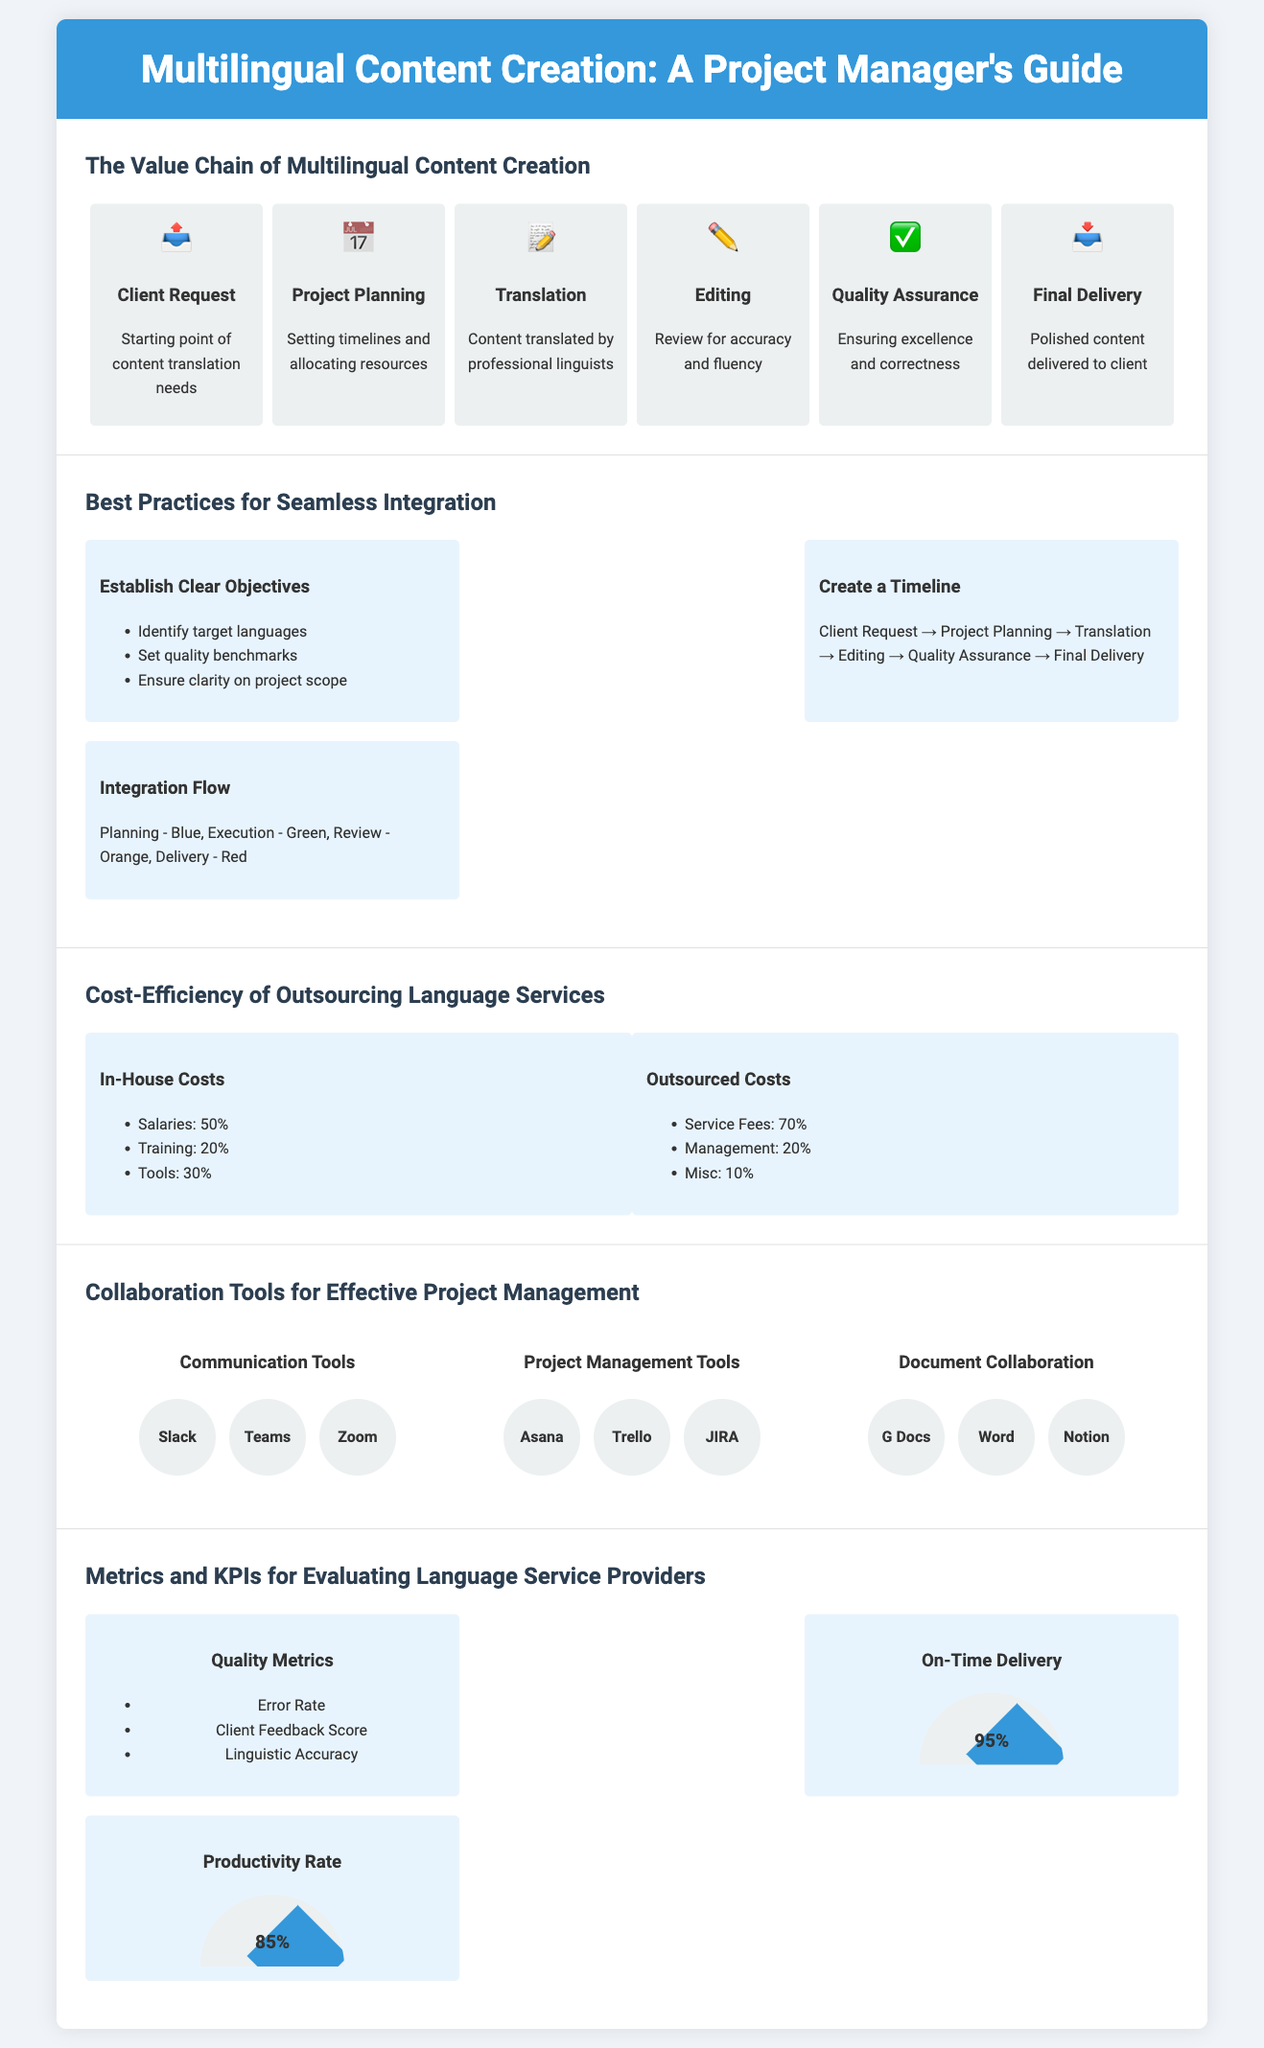What is the starting point of content translation needs? The document specifies "Client Request" as the initial stage in the value chain of multilingual content creation.
Answer: Client Request What are the three main categories of best practices? The document highlights establishing clear objectives, creating a timeline, and integration flow as key practices to ensure seamless integration of language services.
Answer: Establish Clear Objectives, Create a Timeline, Integration Flow What percentage of in-house costs is attributed to salaries? The infographic states that 50% of in-house costs goes to salaries.
Answer: 50% What is the average on-time delivery rate? The speedometer in the metrics section shows an on-time delivery rate of 95%.
Answer: 95% Which tool is listed under project management tools? The document lists "Asana" as one of the project management tools for effective collaboration.
Answer: Asana What does the quality assurance stage ensure? The document states that quality assurance is for "Ensuring excellence and correctness."
Answer: Ensuring excellence and correctness How many items are listed in the quality metrics? The quality metrics section mentions three items, which include error rate, client feedback score, and linguistic accuracy.
Answer: Three What color represents the planning stage in the integration flow? The document specifies that blue is the color designated for the planning stage.
Answer: Blue What is the productivity rate mentioned in the document? The speedometer indicates a productivity rate of 85%.
Answer: 85% 